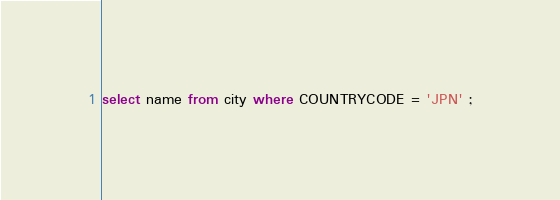<code> <loc_0><loc_0><loc_500><loc_500><_SQL_>select name from city where COUNTRYCODE = 'JPN' ;</code> 